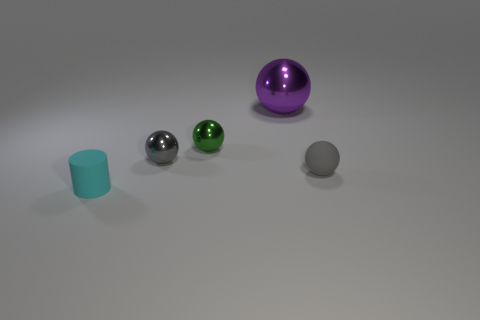There is a matte ball; is it the same color as the metal thing left of the green metallic sphere?
Your answer should be compact. Yes. Are there any big shiny things of the same shape as the small gray metal object?
Offer a very short reply. Yes. Are there fewer small matte spheres behind the small green metal object than blue metallic cubes?
Provide a short and direct response. No. Do the purple shiny object and the tiny green thing have the same shape?
Your response must be concise. Yes. There is a metal ball behind the small green shiny thing; how big is it?
Offer a very short reply. Large. There is a purple thing that is made of the same material as the small green object; what size is it?
Offer a terse response. Large. Are there fewer green objects than large cyan matte cylinders?
Your response must be concise. No. There is a gray ball that is the same size as the gray rubber object; what is it made of?
Offer a terse response. Metal. Are there more tiny rubber cylinders than large yellow things?
Offer a very short reply. Yes. How many other things are the same color as the tiny rubber cylinder?
Make the answer very short. 0. 